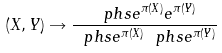<formula> <loc_0><loc_0><loc_500><loc_500>( X , Y ) \rightarrow \frac { \ p h s { e ^ { \pi ( X ) } e ^ { \pi ( Y ) } } } { \ p h s { e ^ { \pi ( X ) } } \ p h s { e ^ { \pi ( Y ) } } }</formula> 